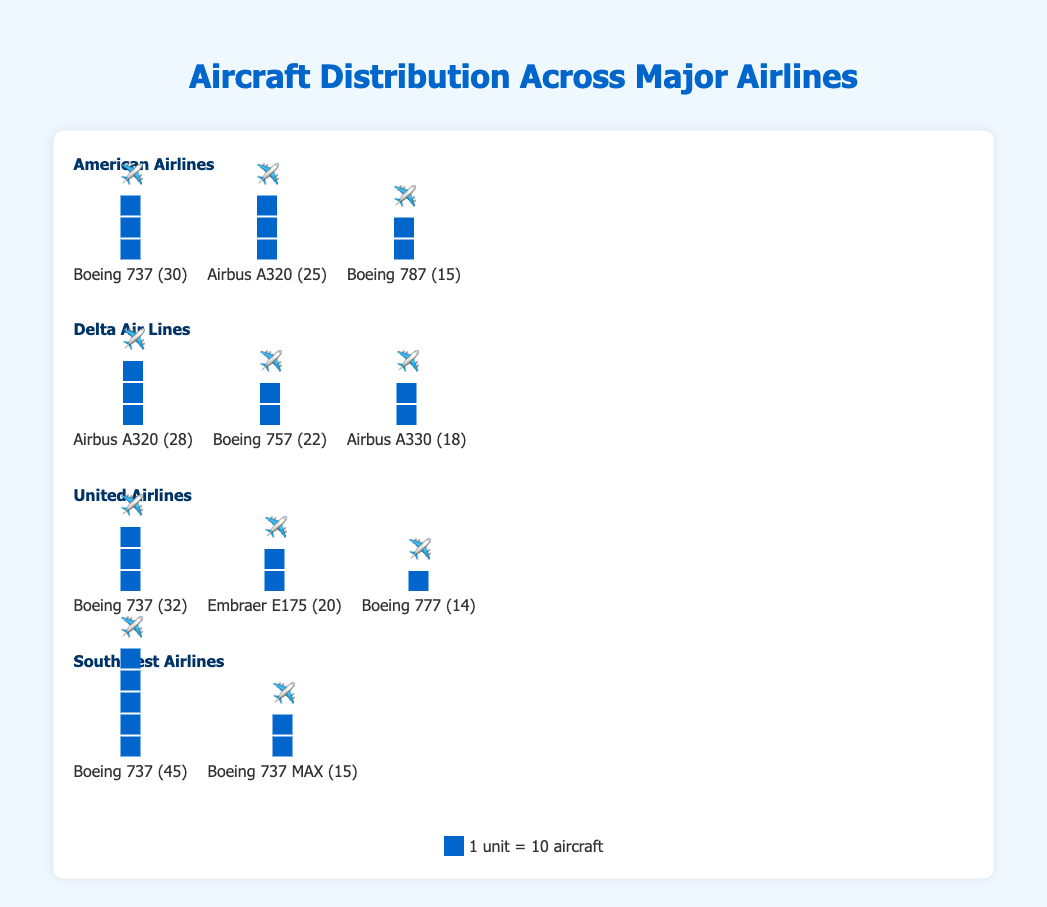What is the total number of aircraft for American Airlines? There are three types of aircraft for American Airlines: Boeing 737 (30), Airbus A320 (25), and Boeing 787 (15). Adding these values gives 30 + 25 + 15 = 70.
Answer: 70 Which airline has the most Boeing 737 aircraft? Comparing the four airlines: American Airlines (30), Delta Air Lines (0), United Airlines (32), and Southwest Airlines (45). The highest count is with Southwest Airlines.
Answer: Southwest Airlines How many more Boeing 737s does Southwest Airlines have compared to American Airlines? Southwest Airlines has 45 Boeing 737s, while American Airlines has 30. The difference is 45 - 30.
Answer: 15 What is the average number of Airbus aircraft for Delta Air Lines? Delta Air Lines has two types of Airbus aircraft: Airbus A320 (28) and Airbus A330 (18). The average is calculated as (28 + 18) / 2 = 23.
Answer: 23 Which airline has the fewest aircraft types in their fleet? By counting the types: American Airlines (3 types), Delta Air Lines (3 types), United Airlines (3 types), and Southwest Airlines (2 types). The fewest is with Southwest Airlines.
Answer: Southwest Airlines What is the total number of aircraft for Delta Air Lines and United Airlines combined? Delta Air Lines has Airbus A320 (28), Boeing 757 (22), and Airbus A330 (18) totaling 28 + 22 + 18 = 68. United Airlines has Boeing 737 (32), Embraer E175 (20), and Boeing 777 (14), totaling 32 + 20 + 14 = 66. Combined, they have 68 + 66 = 134.
Answer: 134 Which airline has the highest count of its most numerous aircraft type? Southwest Airlines' Boeing 737 (45) is compared to American Airlines' Boeing 737 (30), Delta's Airbus A320 (28), and United's Boeing 737 (32). The highest is 45 with Southwest Airlines.
Answer: Southwest Airlines How many non-Boeing aircraft does United Airlines have? United Airlines has ten non-Boeing aircraft (Embraer E175). All other aircraft in United's fleet are Boeings.
Answer: 20 Which airline has more types of Airbus aircraft in their fleet? American Airlines has one type of Airbus (A320), while Delta Air Lines has two (A320 and A330). The airline with more types is Delta Air Lines.
Answer: Delta Air Lines How many total aircraft are there across all four airlines? Summing the counts: American Airlines (70), Delta Air Lines (68), United Airlines (66), and Southwest Airlines (60). Total = 70 + 68 + 66 + 60.
Answer: 264 